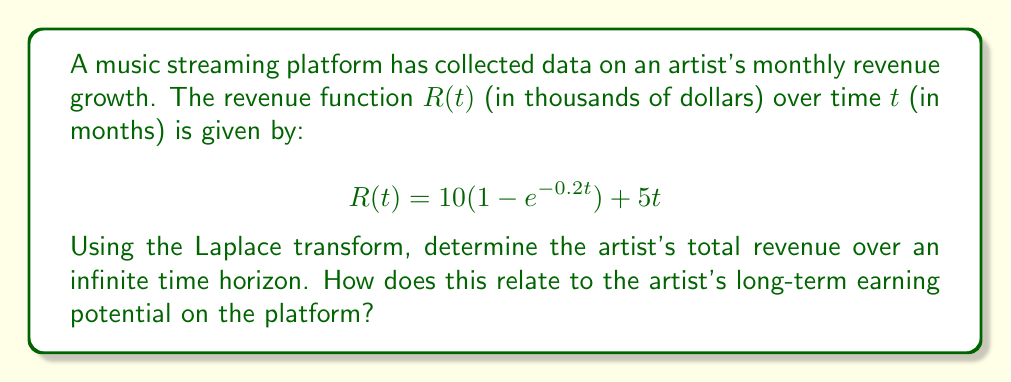Can you answer this question? To solve this problem, we'll use the Laplace transform to analyze the artist's revenue function over an infinite time horizon. Let's break it down step-by-step:

1) First, recall the Laplace transform of $R(t)$:

   $$\mathcal{L}\{R(t)\} = \int_0^\infty R(t)e^{-st}dt$$

2) We need to find $\mathcal{L}\{R(t)\}$ for our given function:

   $$R(t) = 10(1 - e^{-0.2t}) + 5t$$

3) Let's break this into parts:
   
   $R_1(t) = 10$
   $R_2(t) = -10e^{-0.2t}$
   $R_3(t) = 5t$

4) Now, let's find the Laplace transform of each part:

   $\mathcal{L}\{R_1(t)\} = \frac{10}{s}$
   
   $\mathcal{L}\{R_2(t)\} = -\frac{10}{s+0.2}$
   
   $\mathcal{L}\{R_3(t)\} = \frac{5}{s^2}$

5) The Laplace transform of $R(t)$ is the sum of these parts:

   $$\mathcal{L}\{R(t)\} = \frac{10}{s} - \frac{10}{s+0.2} + \frac{5}{s^2}$$

6) To find the total revenue over an infinite time horizon, we need to evaluate this transform at $s = 0$:

   $$\lim_{s \to 0} s\mathcal{L}\{R(t)\} = \lim_{s \to 0} \left(10 - \frac{10s}{s+0.2} + \frac{5}{s}\right)$$

7) Evaluating this limit:

   $$\lim_{s \to 0} s\mathcal{L}\{R(t)\} = 10 - 0 + \infty = \infty$$

This result indicates that the artist's total revenue over an infinite time horizon is infinite. This makes sense because the revenue function includes a linear term $5t$, which grows without bound as time increases.

For the artist's long-term earning potential, we can analyze the rate of growth. As $t$ becomes very large, the exponential term becomes negligible, and the revenue function approximates to:

$$R(t) \approx 10 + 5t$$

This suggests that in the long term, the artist's revenue is growing linearly at a rate of $5,000 per month, with a base of $10,000.
Answer: The artist's total revenue over an infinite time horizon is infinite. In the long term, the revenue grows linearly at a rate of $5,000 per month, indicating strong sustained earning potential on the streaming platform. 